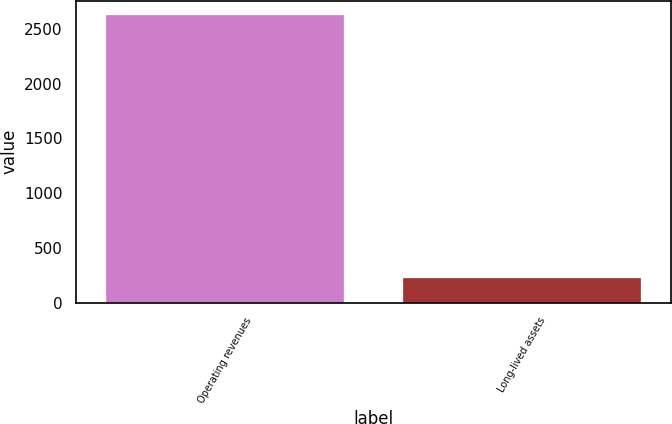<chart> <loc_0><loc_0><loc_500><loc_500><bar_chart><fcel>Operating revenues<fcel>Long-lived assets<nl><fcel>2627.3<fcel>220.7<nl></chart> 